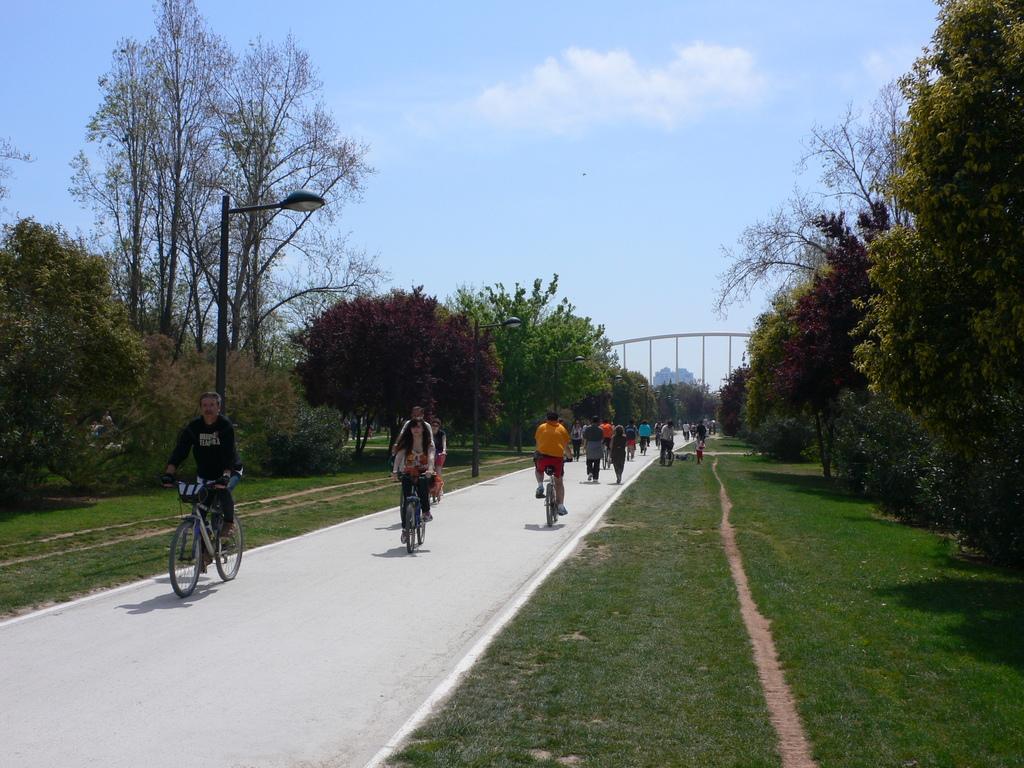In one or two sentences, can you explain what this image depicts? In this image we can see people and few of them are riding bicycles on the road. Here we can see grass, plants, trees, poles, and lights. In the background there is sky with clouds. 